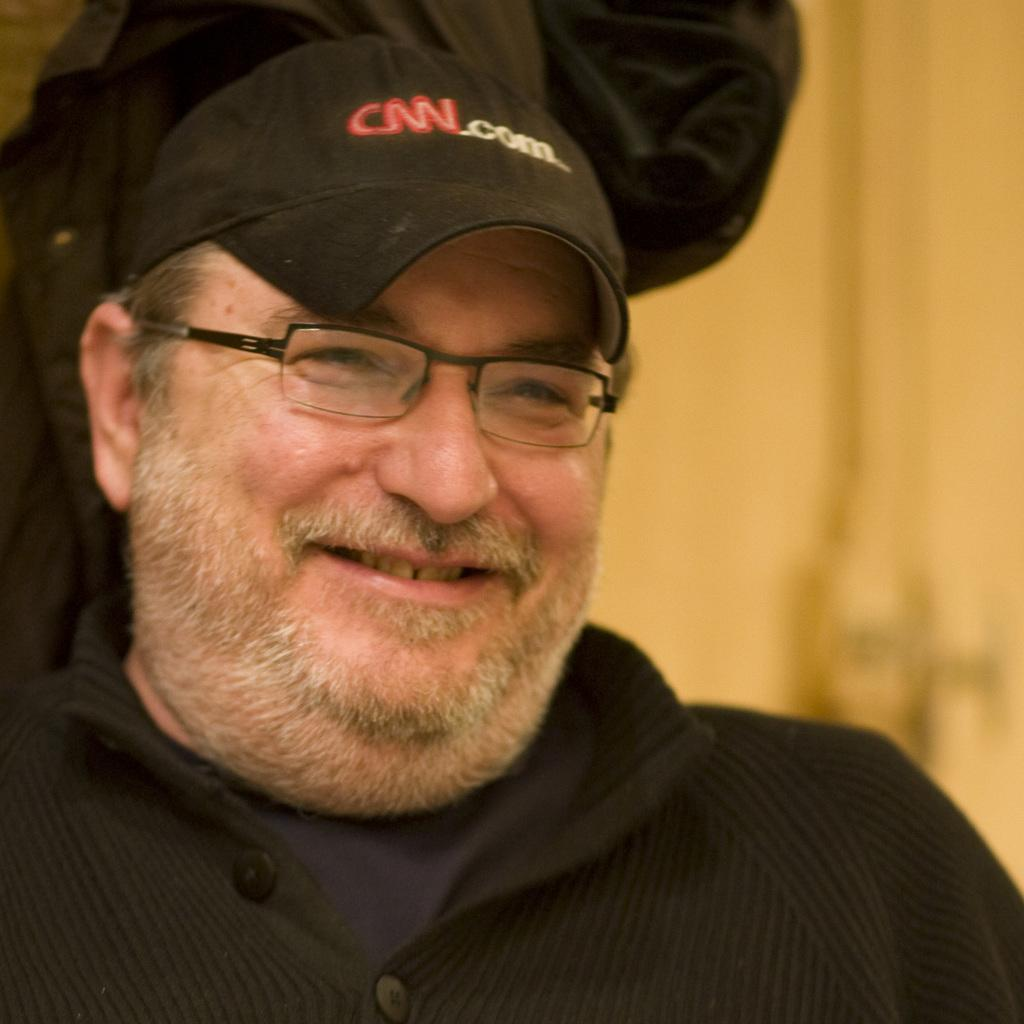Who is present in the image? There is a man in the image. What is the man doing in the image? The man is smiling in the image. What accessories is the man wearing in the image? The man is wearing spectacles and a cap in the image. Can you describe the background of the image? In the background, the image is not clear, and there is a person, objects, and a wall present. Can you see any islands in the background of the image? There are no islands visible in the background of the image. Is the man sneezing in the image? The man is not sneezing in the image; he is smiling. 